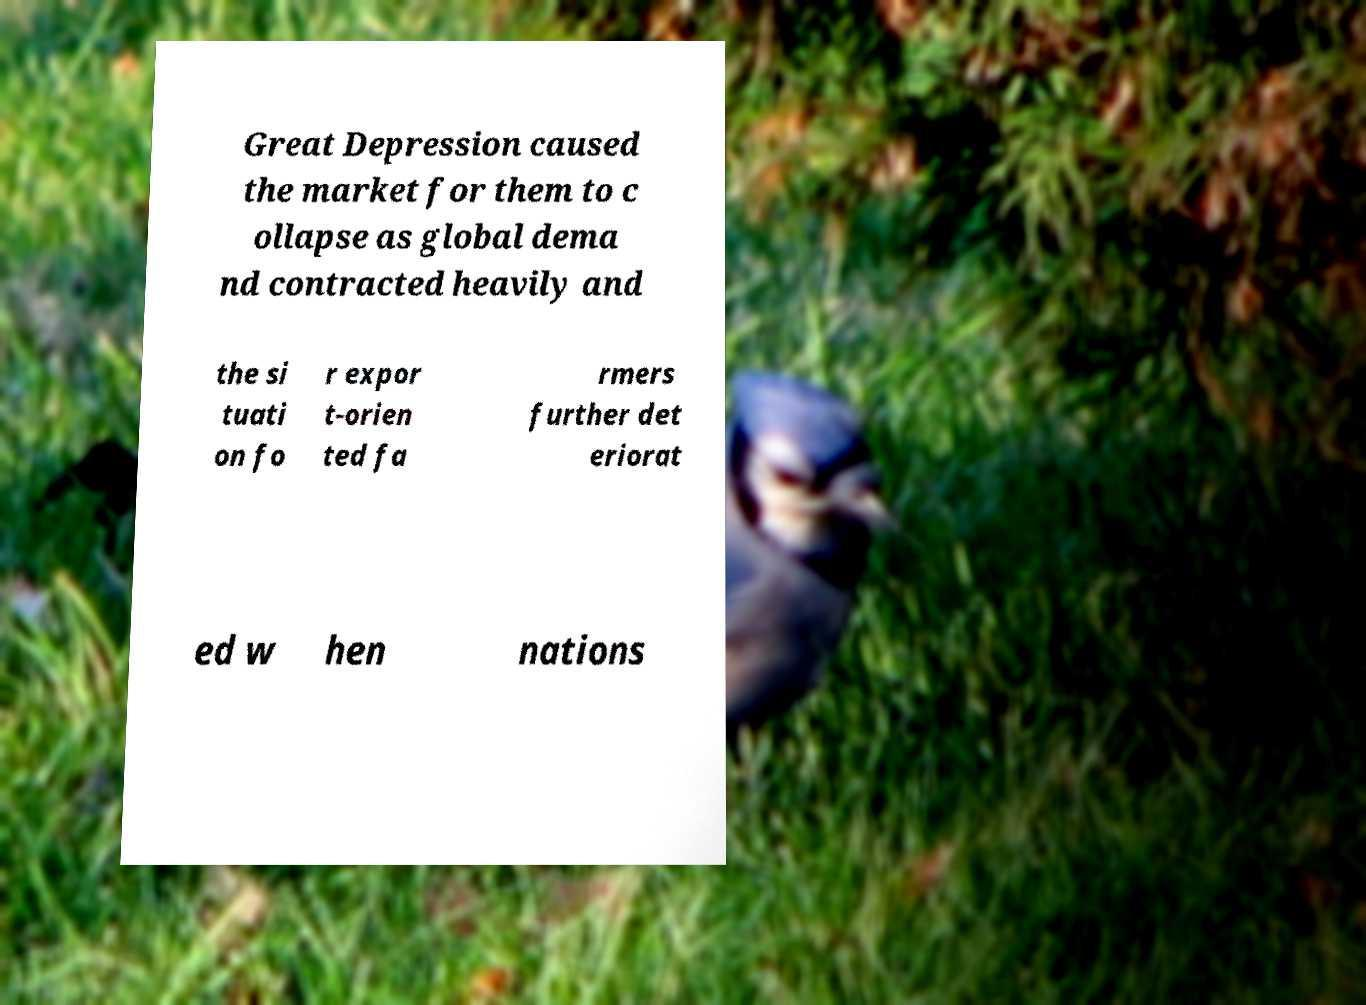Can you read and provide the text displayed in the image?This photo seems to have some interesting text. Can you extract and type it out for me? Great Depression caused the market for them to c ollapse as global dema nd contracted heavily and the si tuati on fo r expor t-orien ted fa rmers further det eriorat ed w hen nations 